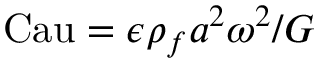Convert formula to latex. <formula><loc_0><loc_0><loc_500><loc_500>C a u = \epsilon \rho _ { f } a ^ { 2 } \omega ^ { 2 } / G</formula> 